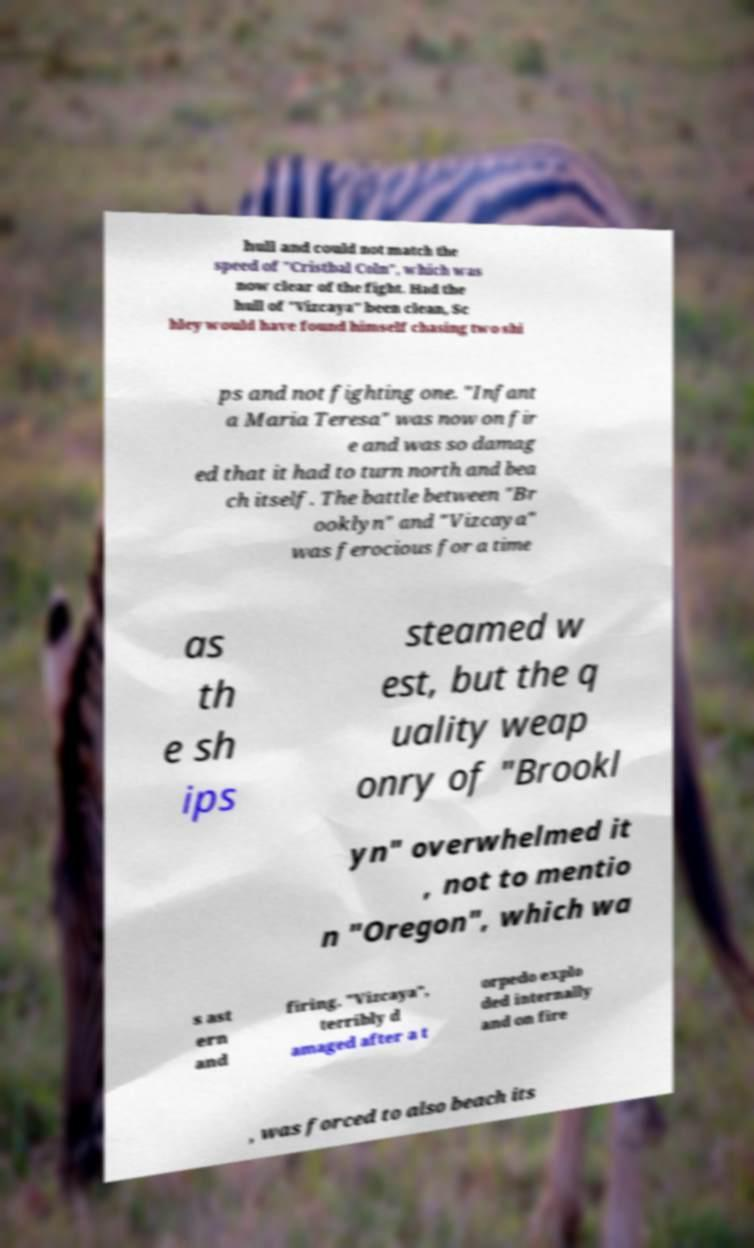There's text embedded in this image that I need extracted. Can you transcribe it verbatim? hull and could not match the speed of "Cristbal Coln", which was now clear of the fight. Had the hull of "Vizcaya" been clean, Sc hley would have found himself chasing two shi ps and not fighting one. "Infant a Maria Teresa" was now on fir e and was so damag ed that it had to turn north and bea ch itself. The battle between "Br ooklyn" and "Vizcaya" was ferocious for a time as th e sh ips steamed w est, but the q uality weap onry of "Brookl yn" overwhelmed it , not to mentio n "Oregon", which wa s ast ern and firing. "Vizcaya", terribly d amaged after a t orpedo explo ded internally and on fire , was forced to also beach its 